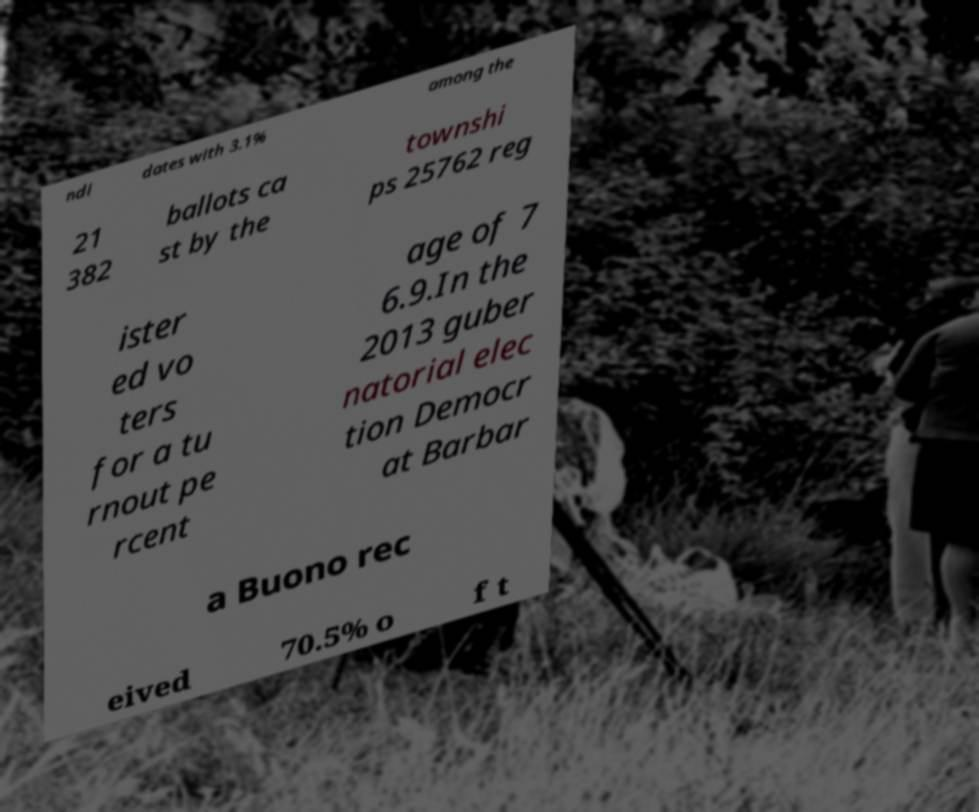Please read and relay the text visible in this image. What does it say? ndi dates with 3.1% among the 21 382 ballots ca st by the townshi ps 25762 reg ister ed vo ters for a tu rnout pe rcent age of 7 6.9.In the 2013 guber natorial elec tion Democr at Barbar a Buono rec eived 70.5% o f t 